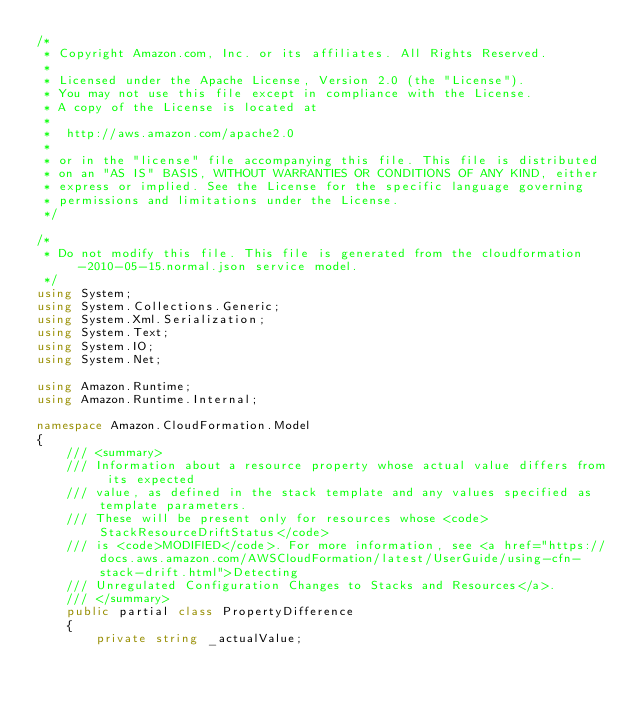Convert code to text. <code><loc_0><loc_0><loc_500><loc_500><_C#_>/*
 * Copyright Amazon.com, Inc. or its affiliates. All Rights Reserved.
 * 
 * Licensed under the Apache License, Version 2.0 (the "License").
 * You may not use this file except in compliance with the License.
 * A copy of the License is located at
 * 
 *  http://aws.amazon.com/apache2.0
 * 
 * or in the "license" file accompanying this file. This file is distributed
 * on an "AS IS" BASIS, WITHOUT WARRANTIES OR CONDITIONS OF ANY KIND, either
 * express or implied. See the License for the specific language governing
 * permissions and limitations under the License.
 */

/*
 * Do not modify this file. This file is generated from the cloudformation-2010-05-15.normal.json service model.
 */
using System;
using System.Collections.Generic;
using System.Xml.Serialization;
using System.Text;
using System.IO;
using System.Net;

using Amazon.Runtime;
using Amazon.Runtime.Internal;

namespace Amazon.CloudFormation.Model
{
    /// <summary>
    /// Information about a resource property whose actual value differs from its expected
    /// value, as defined in the stack template and any values specified as template parameters.
    /// These will be present only for resources whose <code>StackResourceDriftStatus</code>
    /// is <code>MODIFIED</code>. For more information, see <a href="https://docs.aws.amazon.com/AWSCloudFormation/latest/UserGuide/using-cfn-stack-drift.html">Detecting
    /// Unregulated Configuration Changes to Stacks and Resources</a>.
    /// </summary>
    public partial class PropertyDifference
    {
        private string _actualValue;</code> 